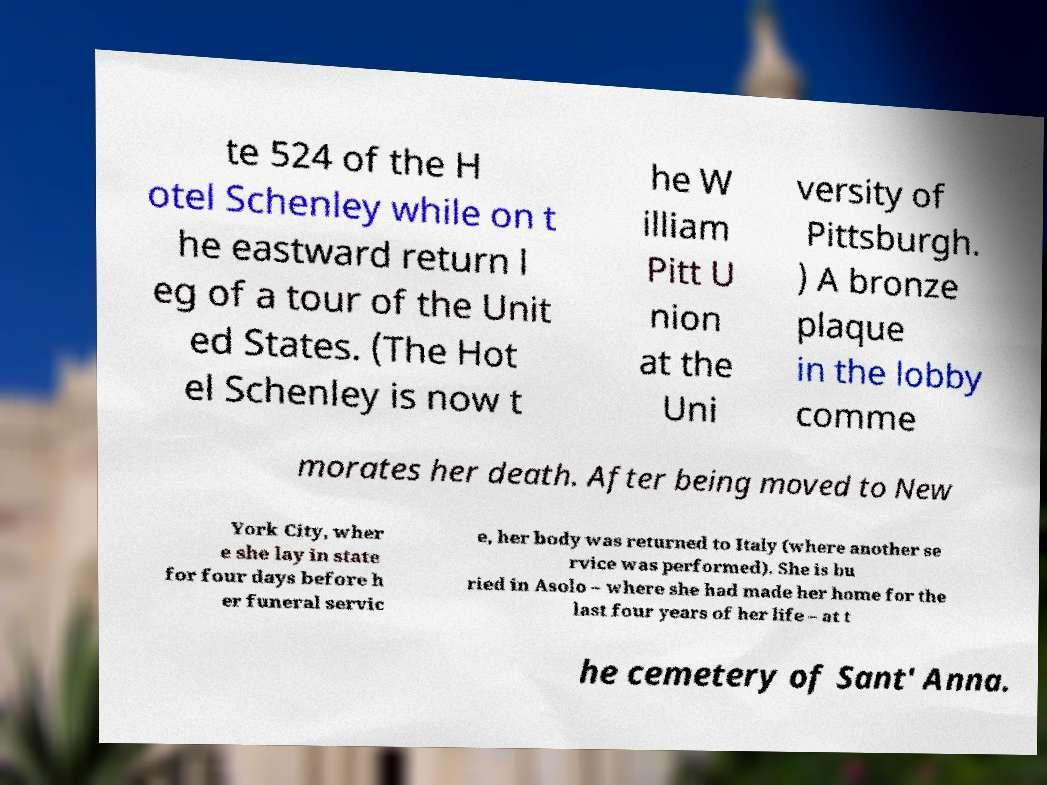I need the written content from this picture converted into text. Can you do that? te 524 of the H otel Schenley while on t he eastward return l eg of a tour of the Unit ed States. (The Hot el Schenley is now t he W illiam Pitt U nion at the Uni versity of Pittsburgh. ) A bronze plaque in the lobby comme morates her death. After being moved to New York City, wher e she lay in state for four days before h er funeral servic e, her body was returned to Italy (where another se rvice was performed). She is bu ried in Asolo – where she had made her home for the last four years of her life – at t he cemetery of Sant' Anna. 